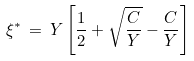Convert formula to latex. <formula><loc_0><loc_0><loc_500><loc_500>\xi ^ { * } \, = \, Y \left [ \frac { 1 } { 2 } + \sqrt { \frac { C } { Y } } - \frac { C } { Y } \right ]</formula> 